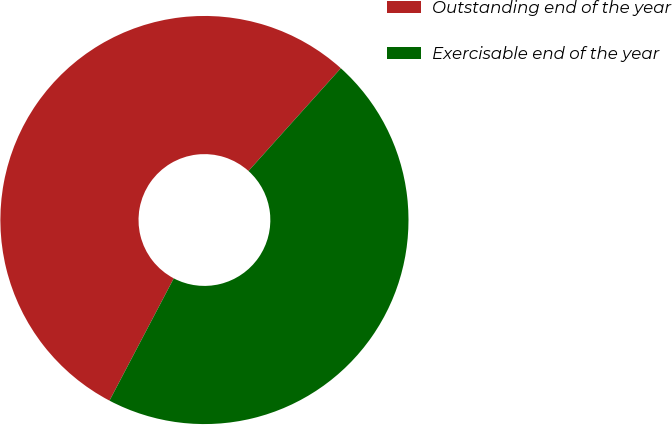<chart> <loc_0><loc_0><loc_500><loc_500><pie_chart><fcel>Outstanding end of the year<fcel>Exercisable end of the year<nl><fcel>53.95%<fcel>46.05%<nl></chart> 